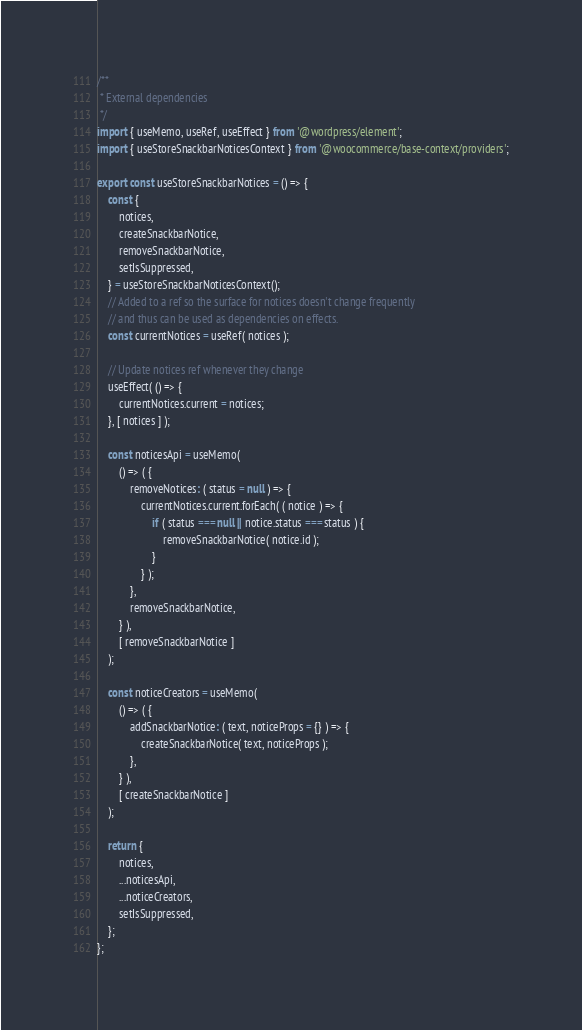<code> <loc_0><loc_0><loc_500><loc_500><_JavaScript_>/**
 * External dependencies
 */
import { useMemo, useRef, useEffect } from '@wordpress/element';
import { useStoreSnackbarNoticesContext } from '@woocommerce/base-context/providers';

export const useStoreSnackbarNotices = () => {
	const {
		notices,
		createSnackbarNotice,
		removeSnackbarNotice,
		setIsSuppressed,
	} = useStoreSnackbarNoticesContext();
	// Added to a ref so the surface for notices doesn't change frequently
	// and thus can be used as dependencies on effects.
	const currentNotices = useRef( notices );

	// Update notices ref whenever they change
	useEffect( () => {
		currentNotices.current = notices;
	}, [ notices ] );

	const noticesApi = useMemo(
		() => ( {
			removeNotices: ( status = null ) => {
				currentNotices.current.forEach( ( notice ) => {
					if ( status === null || notice.status === status ) {
						removeSnackbarNotice( notice.id );
					}
				} );
			},
			removeSnackbarNotice,
		} ),
		[ removeSnackbarNotice ]
	);

	const noticeCreators = useMemo(
		() => ( {
			addSnackbarNotice: ( text, noticeProps = {} ) => {
				createSnackbarNotice( text, noticeProps );
			},
		} ),
		[ createSnackbarNotice ]
	);

	return {
		notices,
		...noticesApi,
		...noticeCreators,
		setIsSuppressed,
	};
};
</code> 